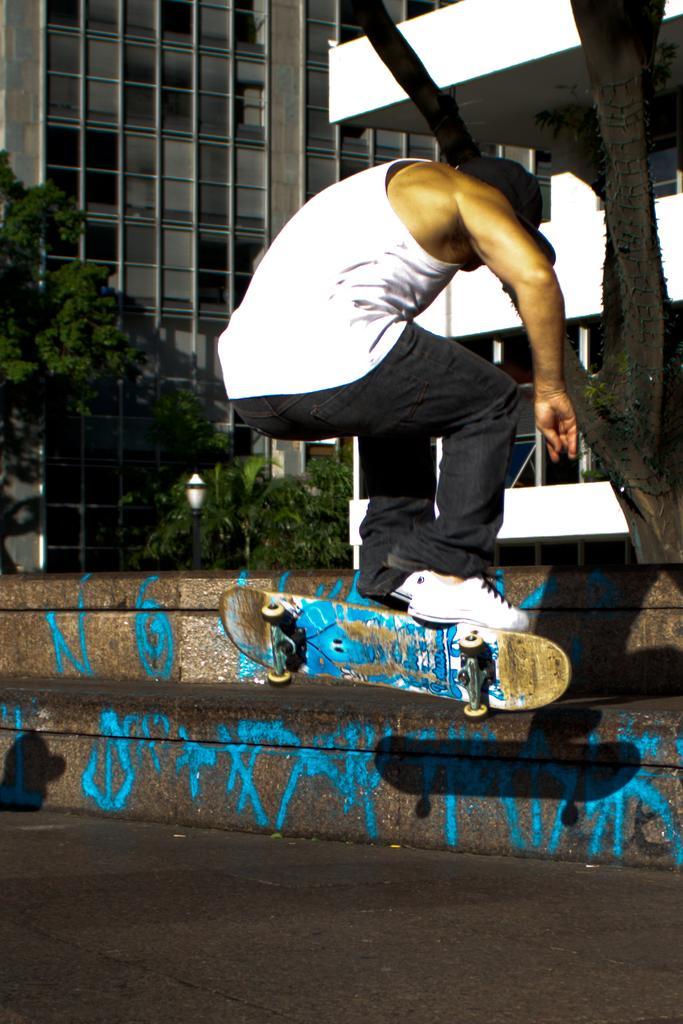Please provide a concise description of this image. In this image we can see a person on a skateboard. Also there is road. And there are steps. In the back there are trees and buildings. 